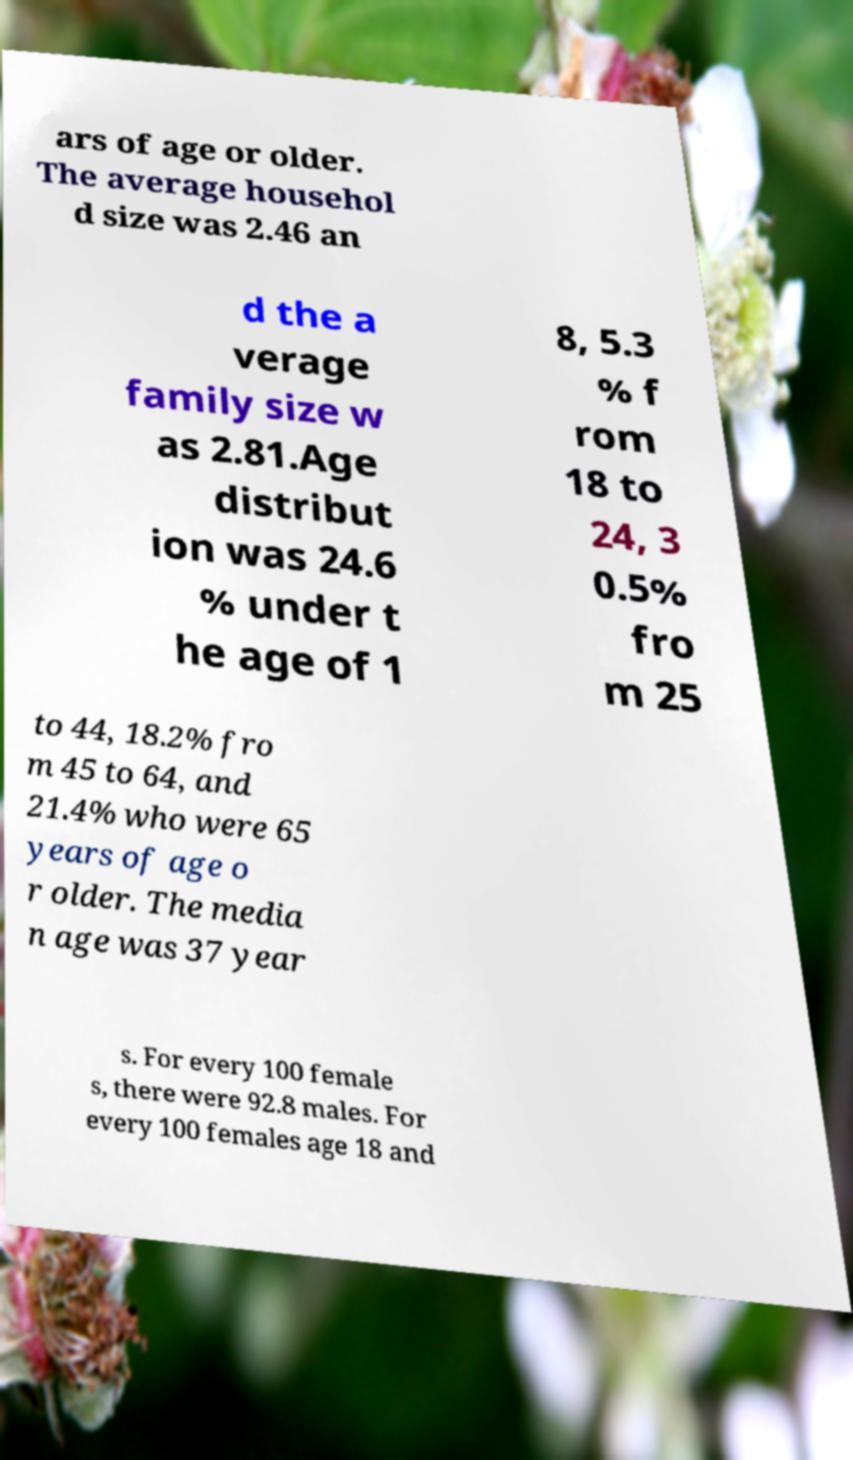Could you extract and type out the text from this image? ars of age or older. The average househol d size was 2.46 an d the a verage family size w as 2.81.Age distribut ion was 24.6 % under t he age of 1 8, 5.3 % f rom 18 to 24, 3 0.5% fro m 25 to 44, 18.2% fro m 45 to 64, and 21.4% who were 65 years of age o r older. The media n age was 37 year s. For every 100 female s, there were 92.8 males. For every 100 females age 18 and 